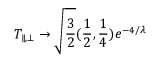Convert formula to latex. <formula><loc_0><loc_0><loc_500><loc_500>T _ { \| , \bot } \to \sqrt { { \frac { 3 } { 2 } } } ( { \frac { 1 } { 2 } } , { \frac { 1 } { 4 } } ) e ^ { - 4 / \lambda }</formula> 